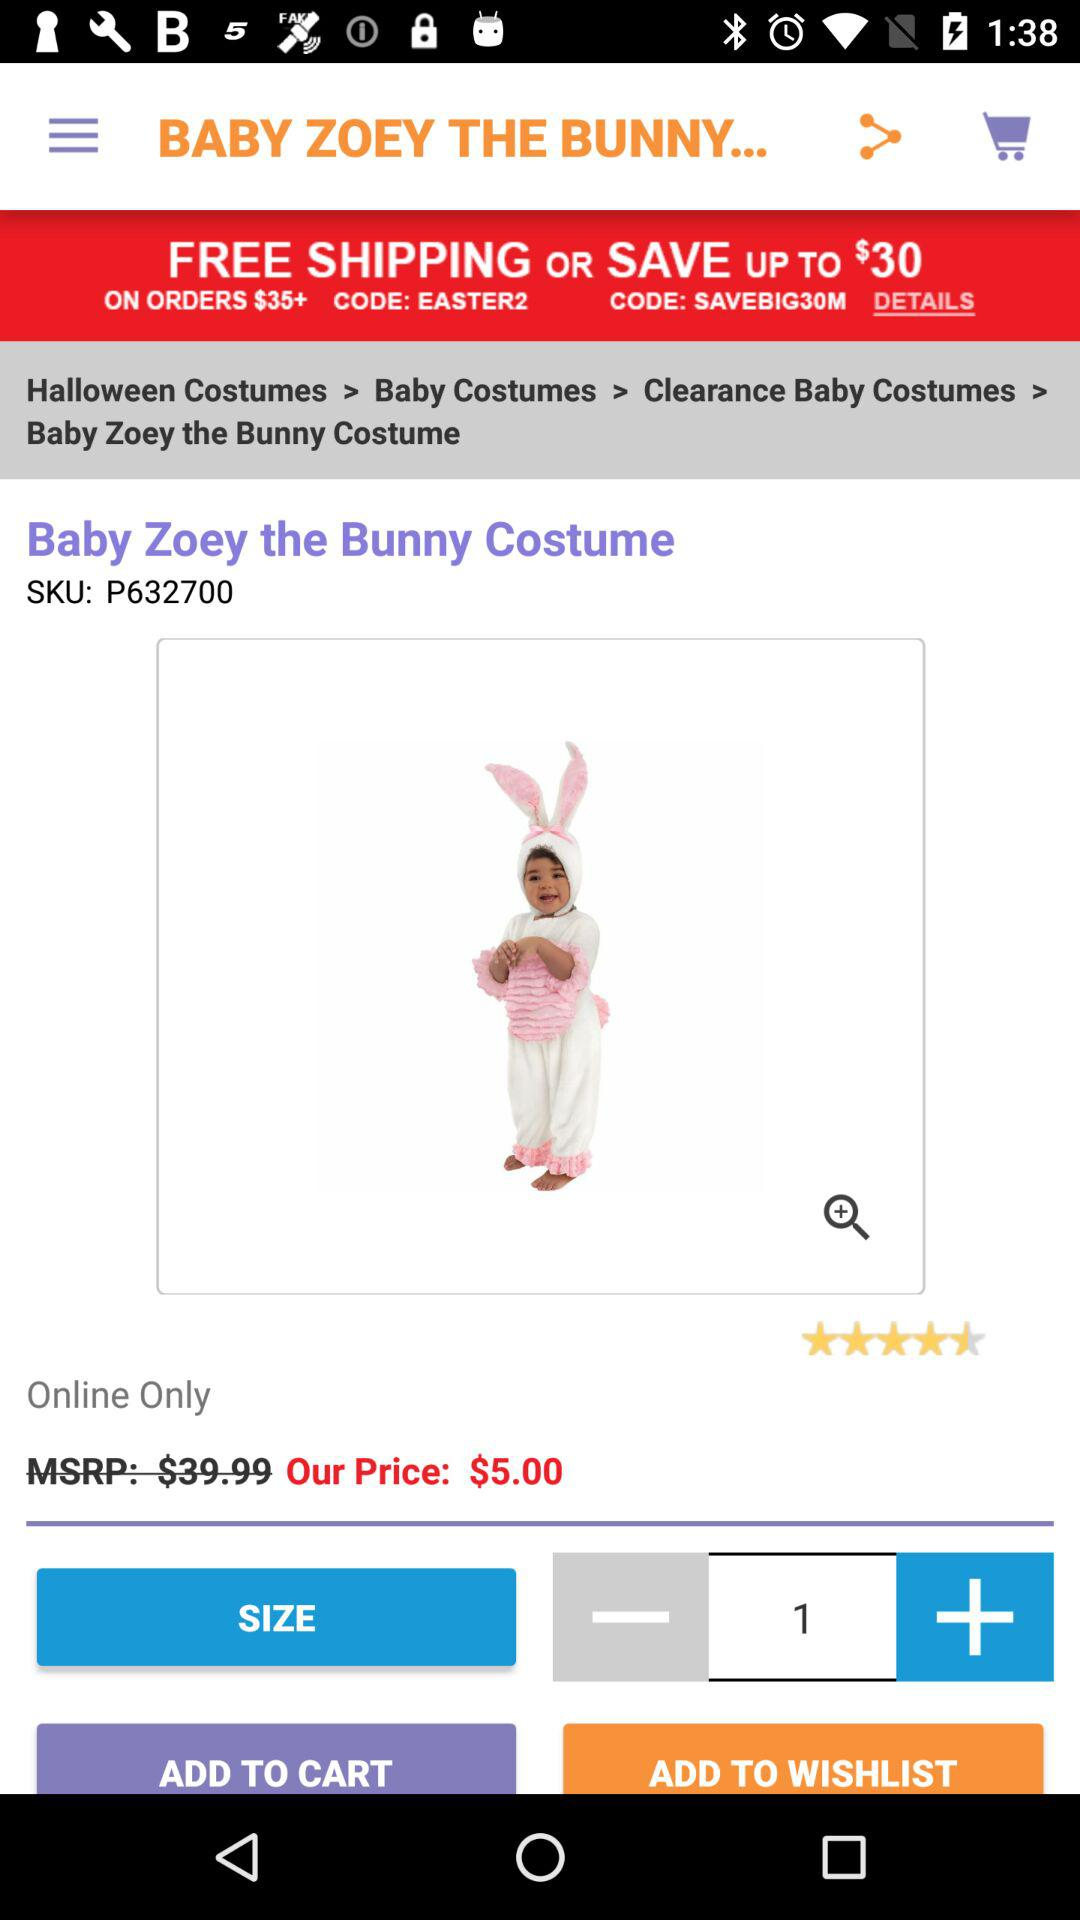What is the code for free shipping? The code for free shipping is "EASTER2". 